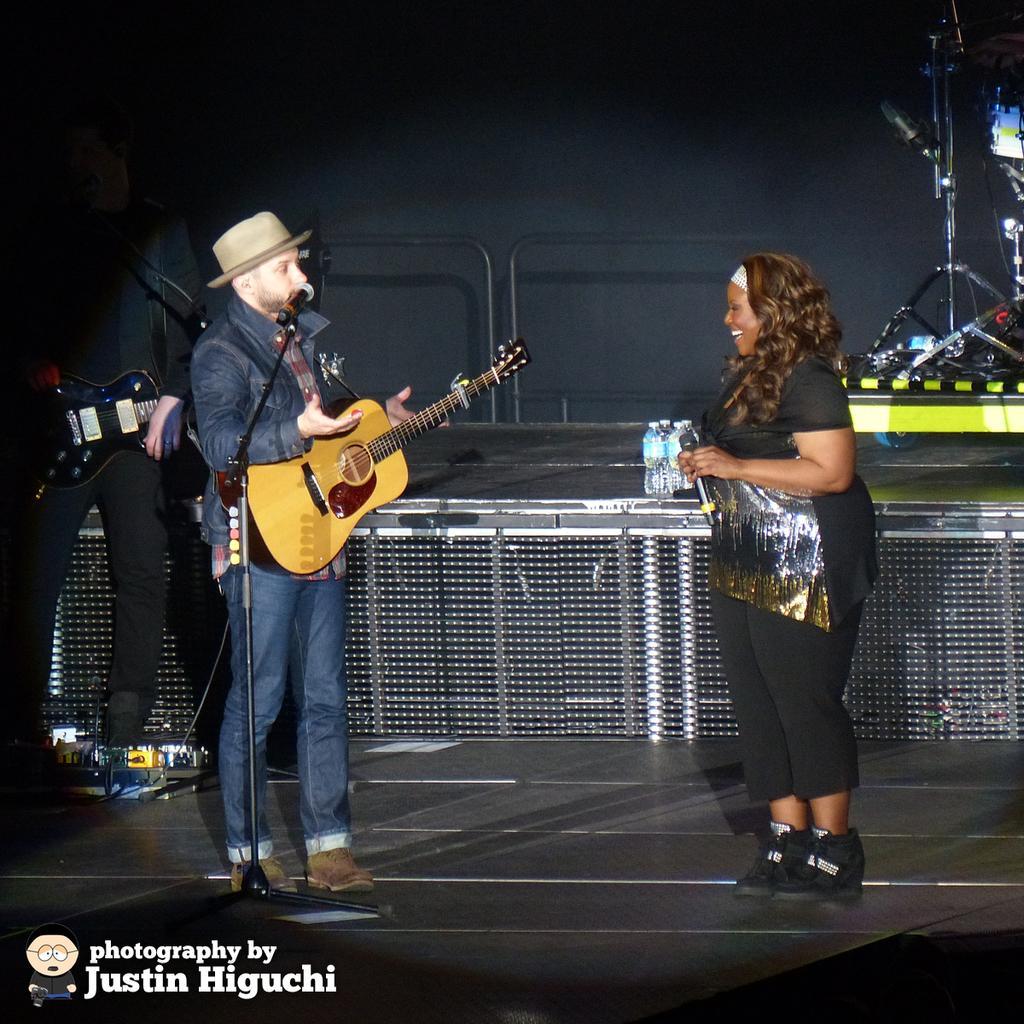Describe this image in one or two sentences. In the middle of the image a woman is standing and holding a microphone. Bottom left side of the image a man is standing and holding a guitar. Top left side of the image a man is standing and holding a guitar. In the middle of the image there is a microphone. In the middle of the image there are some water bottles. 